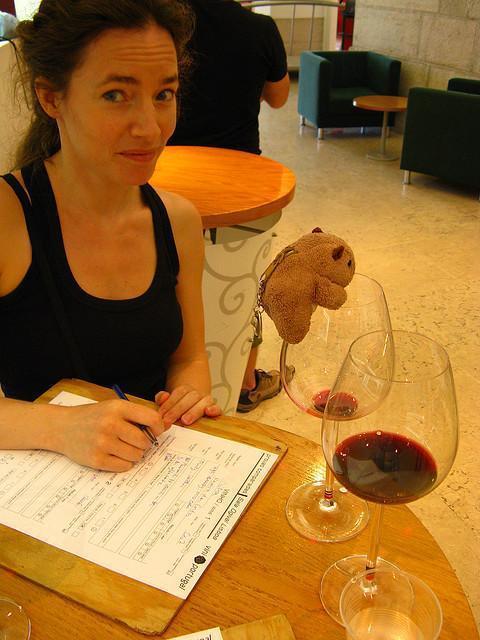What does it look like the stuffed animal is doing?
Pick the right solution, then justify: 'Answer: answer
Rationale: rationale.'
Options: Eating, drinking, singing, attacking. Answer: drinking.
Rationale: It looks like it's trying to get the wine in the glass. 